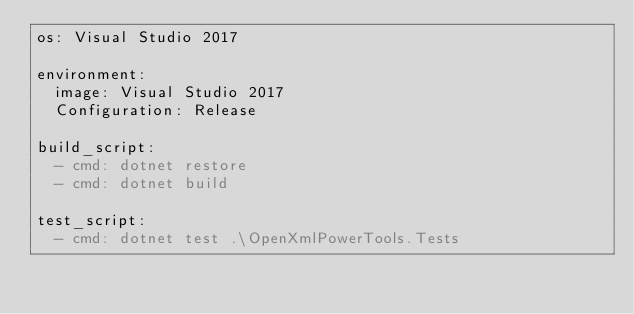Convert code to text. <code><loc_0><loc_0><loc_500><loc_500><_YAML_>os: Visual Studio 2017

environment:
  image: Visual Studio 2017
  Configuration: Release

build_script:
  - cmd: dotnet restore
  - cmd: dotnet build

test_script:
  - cmd: dotnet test .\OpenXmlPowerTools.Tests
</code> 